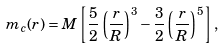<formula> <loc_0><loc_0><loc_500><loc_500>m _ { c } ( r ) = M \left [ \frac { 5 } { 2 } \left ( \frac { r } { R } \right ) ^ { 3 } - \frac { 3 } { 2 } \left ( \frac { r } { R } \right ) ^ { 5 } \right ] ,</formula> 